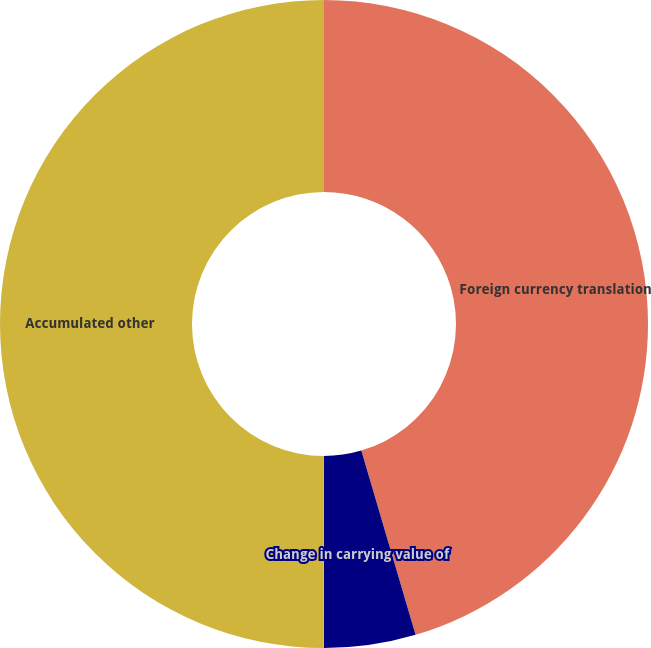Convert chart. <chart><loc_0><loc_0><loc_500><loc_500><pie_chart><fcel>Foreign currency translation<fcel>Change in carrying value of<fcel>Unrealized gain on derivatives<fcel>Accumulated other<nl><fcel>45.44%<fcel>4.56%<fcel>0.02%<fcel>49.98%<nl></chart> 